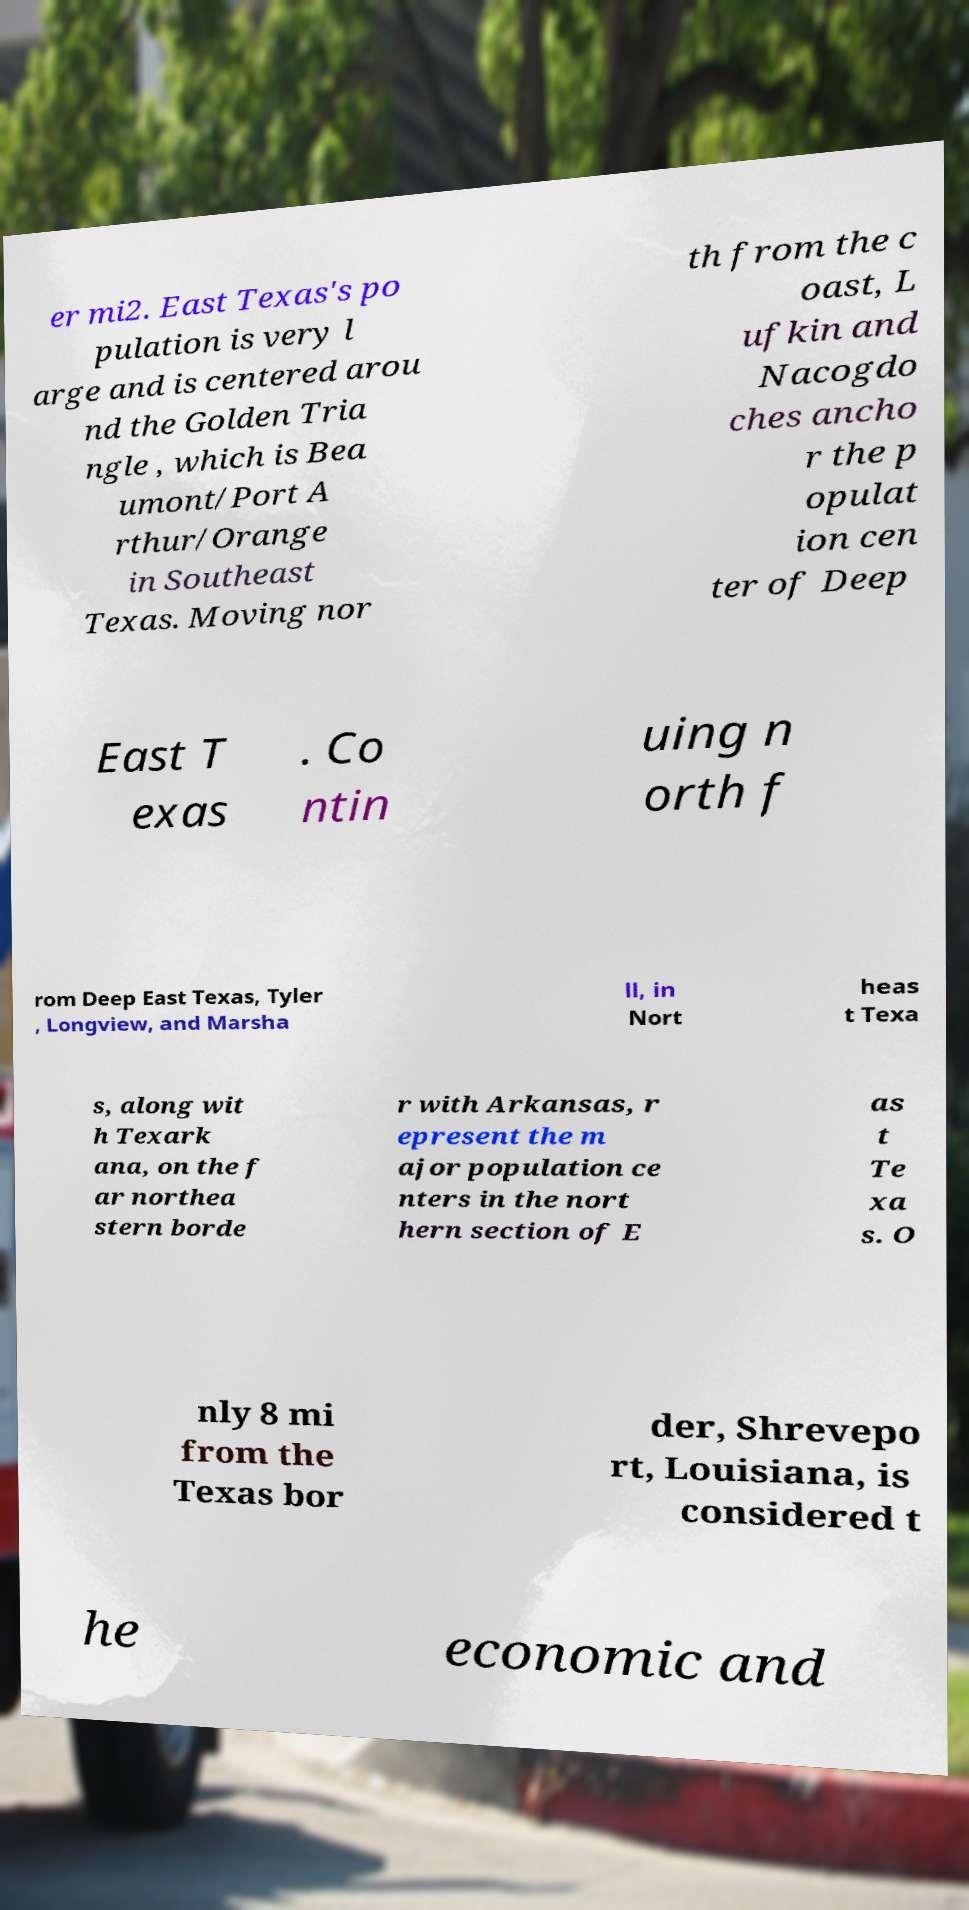Could you extract and type out the text from this image? er mi2. East Texas's po pulation is very l arge and is centered arou nd the Golden Tria ngle , which is Bea umont/Port A rthur/Orange in Southeast Texas. Moving nor th from the c oast, L ufkin and Nacogdo ches ancho r the p opulat ion cen ter of Deep East T exas . Co ntin uing n orth f rom Deep East Texas, Tyler , Longview, and Marsha ll, in Nort heas t Texa s, along wit h Texark ana, on the f ar northea stern borde r with Arkansas, r epresent the m ajor population ce nters in the nort hern section of E as t Te xa s. O nly 8 mi from the Texas bor der, Shrevepo rt, Louisiana, is considered t he economic and 